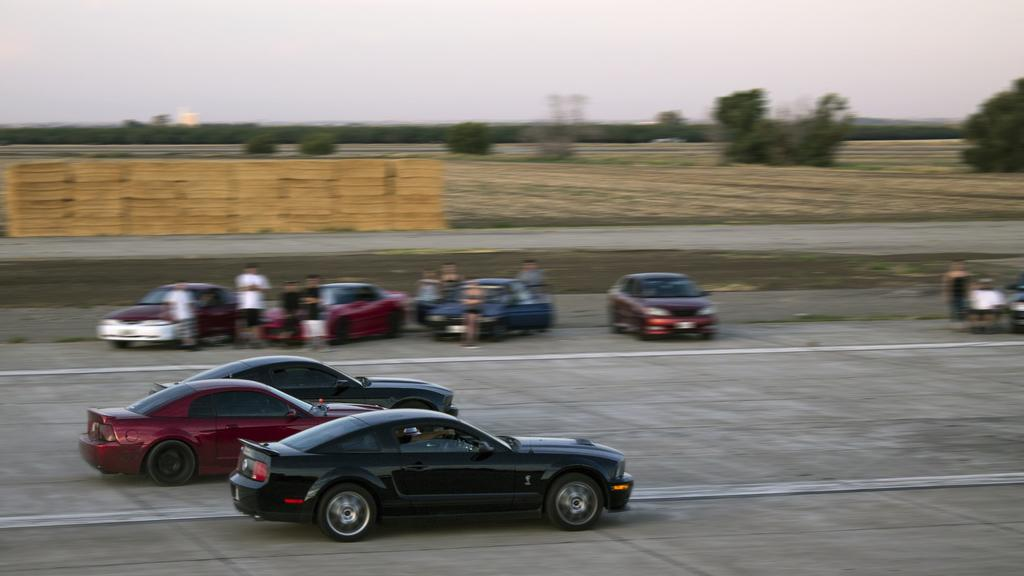What type of vehicles can be seen in the image? There are cars in the image. What are the people on the road doing? The people standing on the road are visible in the image. What type of vegetation is present in the image? There are trees in the image. What can be seen in the distance in the image? The sky is visible in the background of the image. What color is the string attached to the balloon in the image? There is no balloon or string in the image. How do the people on the road say good-bye to each other in the image? There is no indication of people saying good-bye in the image. 